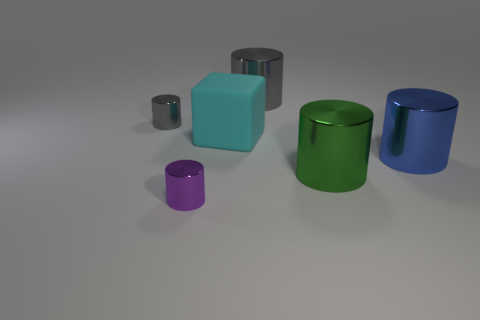Add 1 green shiny things. How many objects exist? 7 Subtract all big blue cylinders. How many cylinders are left? 4 Add 1 purple metal cylinders. How many purple metal cylinders are left? 2 Add 2 large metal things. How many large metal things exist? 5 Subtract all green cylinders. How many cylinders are left? 4 Subtract 0 gray balls. How many objects are left? 6 Subtract all blocks. How many objects are left? 5 Subtract all red cylinders. Subtract all cyan balls. How many cylinders are left? 5 Subtract all gray cylinders. How many brown blocks are left? 0 Subtract all gray things. Subtract all blue shiny cylinders. How many objects are left? 3 